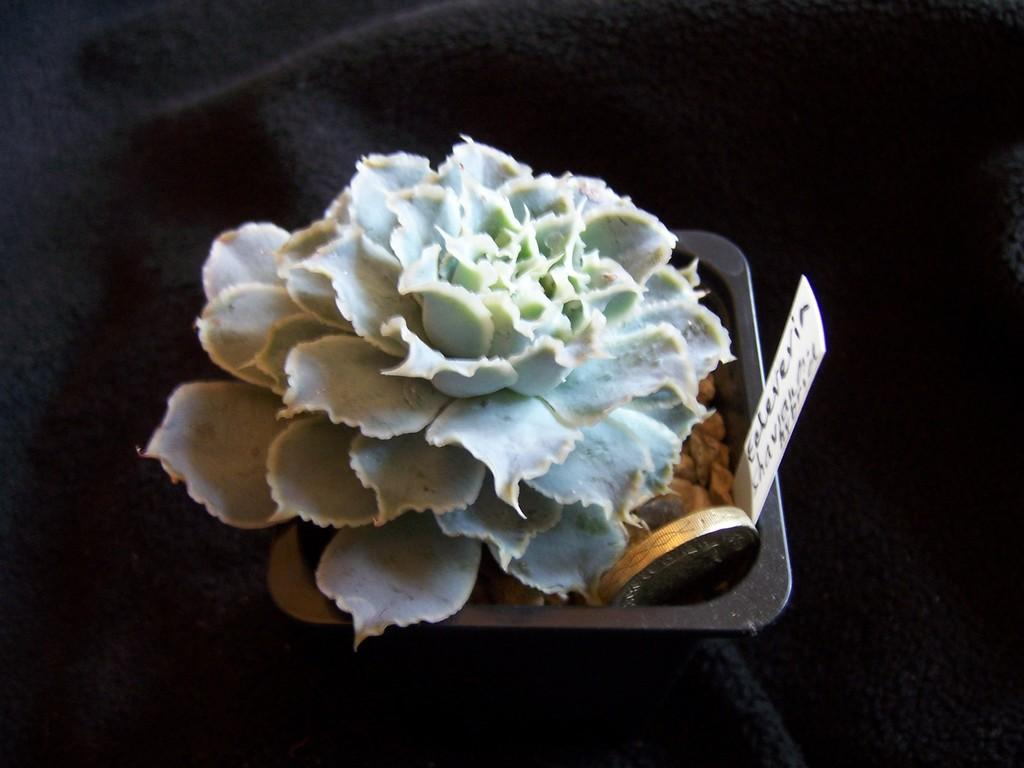What is the main subject of the image? There is a houseplant in the center of the image. Can you describe the houseplant in more detail? Unfortunately, the image does not provide enough detail to describe the houseplant further. What type of beast is causing trouble in the image? There is no beast present in the image; it only features a houseplant. 